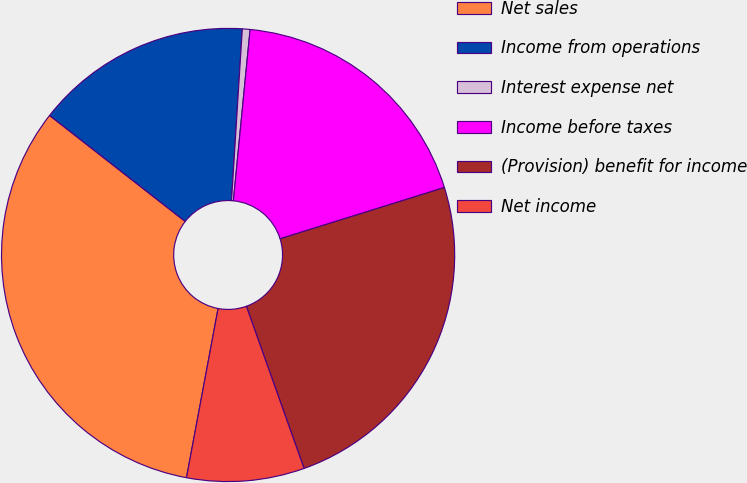Convert chart to OTSL. <chart><loc_0><loc_0><loc_500><loc_500><pie_chart><fcel>Net sales<fcel>Income from operations<fcel>Interest expense net<fcel>Income before taxes<fcel>(Provision) benefit for income<fcel>Net income<nl><fcel>32.62%<fcel>15.44%<fcel>0.55%<fcel>18.64%<fcel>24.37%<fcel>8.38%<nl></chart> 